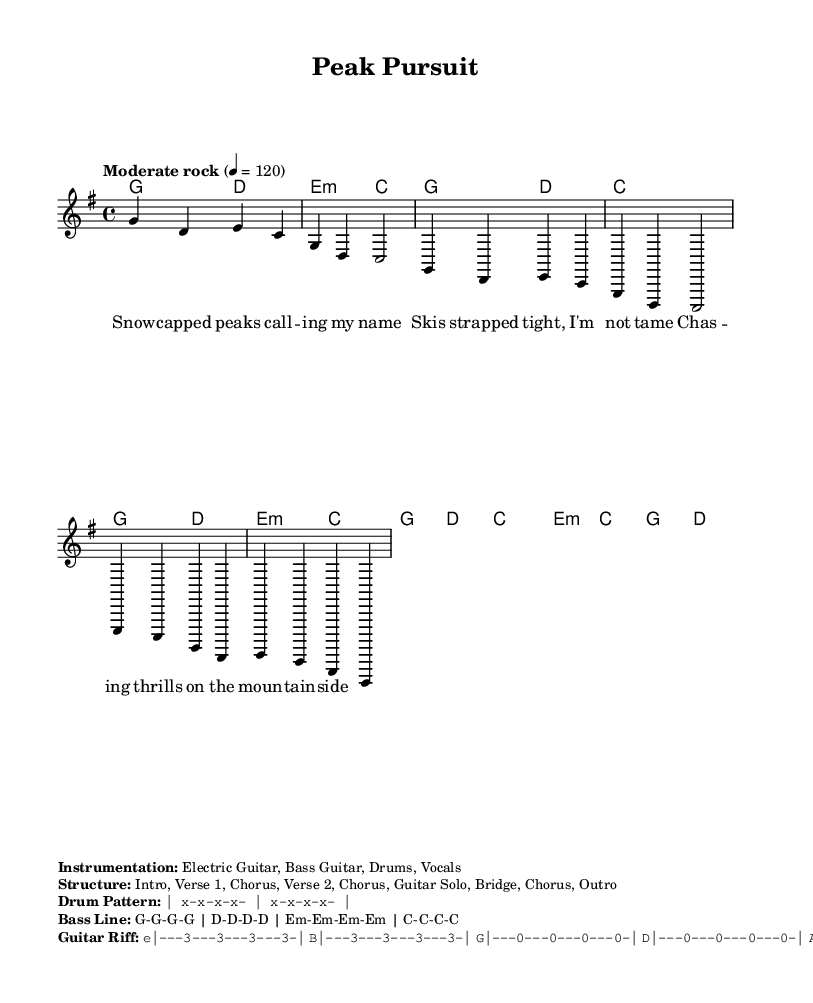What is the key signature of this music? The key signature is G major, which has one sharp (F#). This can be observed in the global settings at the beginning of the sheet music.
Answer: G major What is the time signature of the piece? The time signature is 4/4, which indicates that there are four beats in each measure. This is evident in the global settings, where it specifies the time signature right at the start.
Answer: 4/4 What is the tempo marking for the piece? The tempo marking indicates "Moderate rock" at a speed of 120 beats per minute. This is found in the global section where the tempo is defined.
Answer: Moderate rock List the instrumentation indicated in the sheet music. The instrumentation is Electric Guitar, Bass Guitar, Drums, and Vocals, as stated in the markup section detailing the instrumentation.
Answer: Electric Guitar, Bass Guitar, Drums, Vocals What is the structure of the song? The song structure is outlined as Intro, Verse 1, Chorus, Verse 2, Chorus, Guitar Solo, Bridge, Chorus, Outro. This is highlighted in the markup section that lists the structure.
Answer: Intro, Verse 1, Chorus, Verse 2, Chorus, Guitar Solo, Bridge, Chorus, Outro How many measures are in the provided chorus snippet? The chorus snippet consists of two measures, which is clear when counting the measures in the melody part where the chorus lyrics are placed.
Answer: 2 measures 